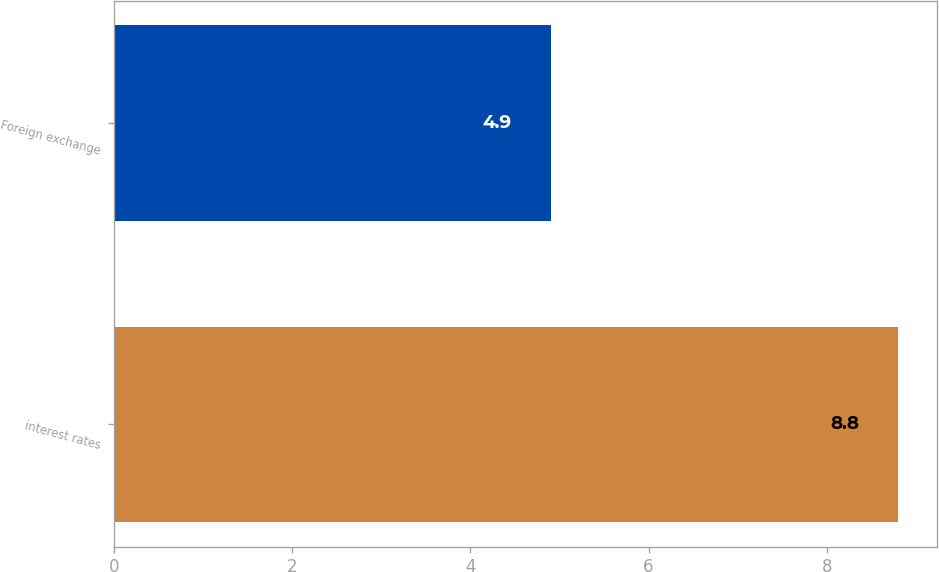Convert chart to OTSL. <chart><loc_0><loc_0><loc_500><loc_500><bar_chart><fcel>interest rates<fcel>Foreign exchange<nl><fcel>8.8<fcel>4.9<nl></chart> 